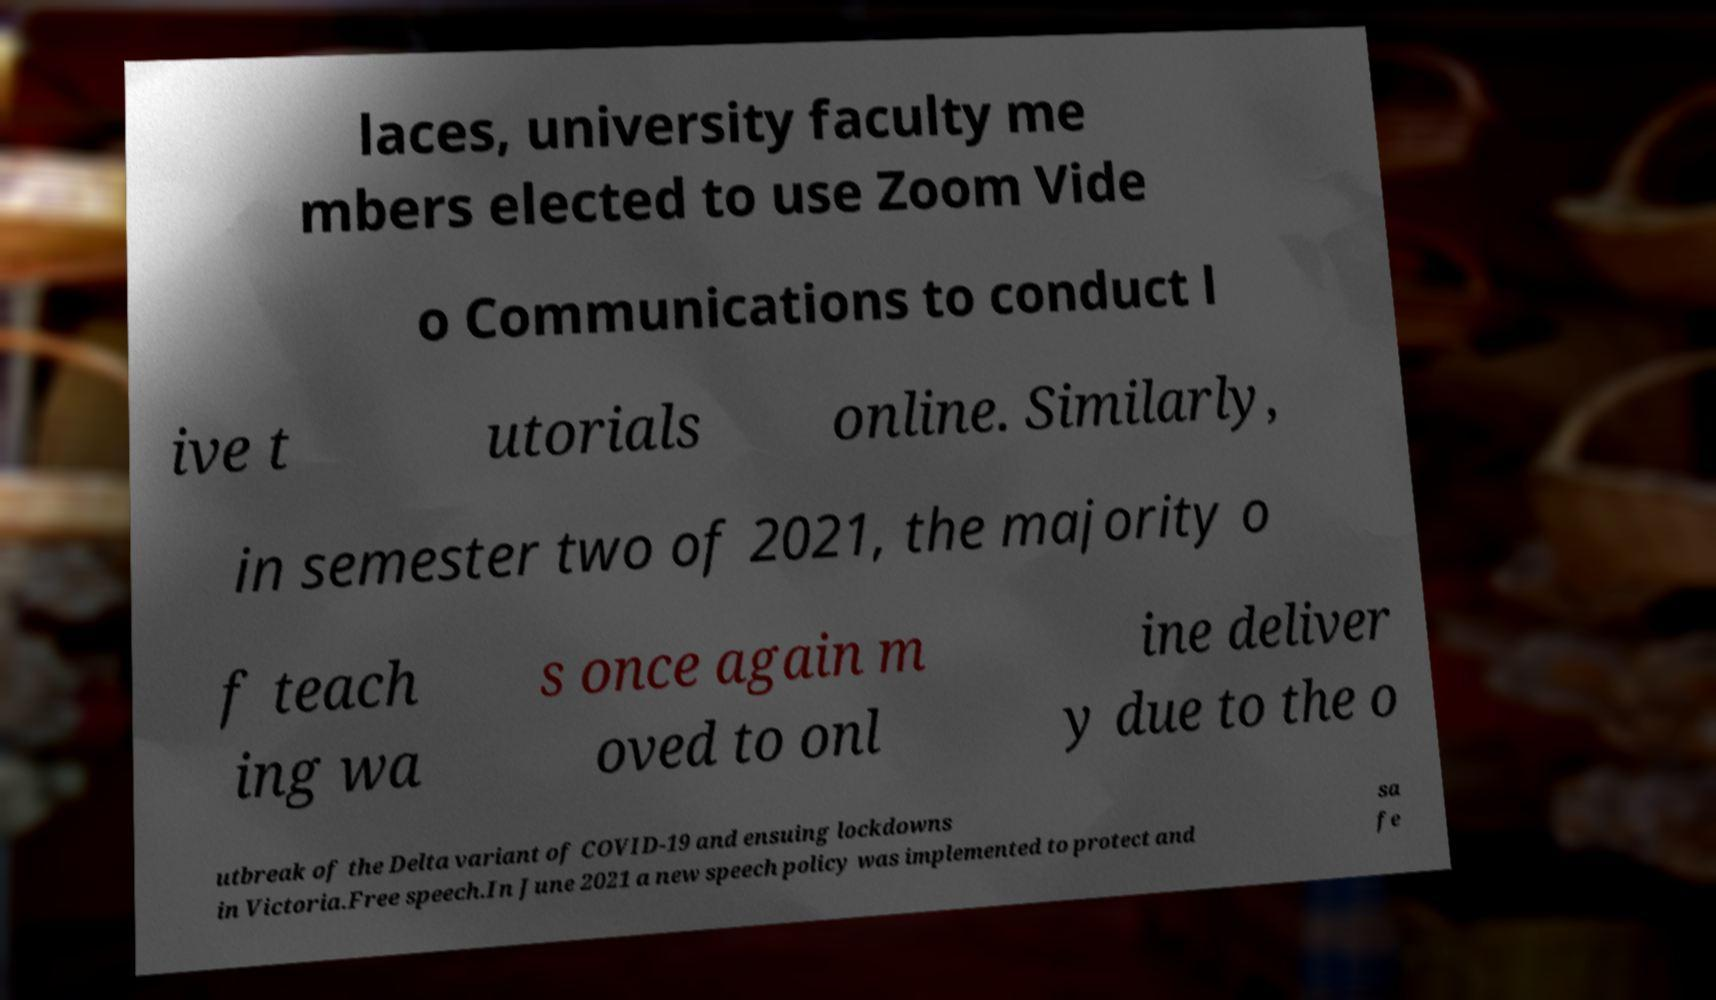Can you read and provide the text displayed in the image?This photo seems to have some interesting text. Can you extract and type it out for me? laces, university faculty me mbers elected to use Zoom Vide o Communications to conduct l ive t utorials online. Similarly, in semester two of 2021, the majority o f teach ing wa s once again m oved to onl ine deliver y due to the o utbreak of the Delta variant of COVID-19 and ensuing lockdowns in Victoria.Free speech.In June 2021 a new speech policy was implemented to protect and sa fe 